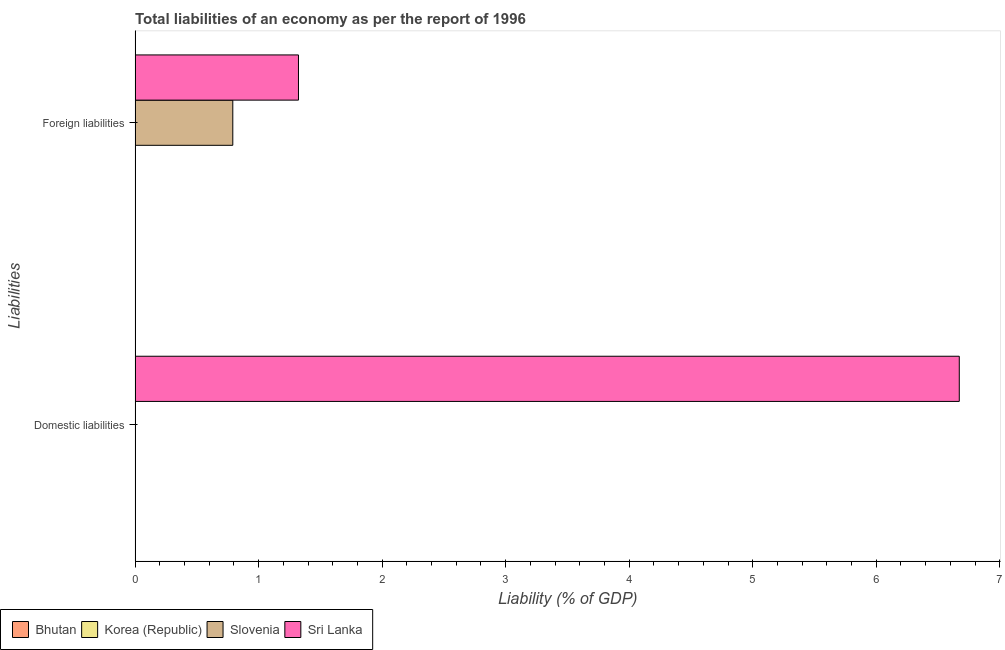How many different coloured bars are there?
Your answer should be compact. 2. Are the number of bars per tick equal to the number of legend labels?
Your answer should be compact. No. Are the number of bars on each tick of the Y-axis equal?
Offer a very short reply. No. How many bars are there on the 1st tick from the top?
Give a very brief answer. 2. How many bars are there on the 2nd tick from the bottom?
Provide a short and direct response. 2. What is the label of the 2nd group of bars from the top?
Your answer should be very brief. Domestic liabilities. What is the incurrence of domestic liabilities in Bhutan?
Offer a terse response. 0. Across all countries, what is the maximum incurrence of domestic liabilities?
Offer a terse response. 6.67. In which country was the incurrence of foreign liabilities maximum?
Provide a short and direct response. Sri Lanka. What is the total incurrence of domestic liabilities in the graph?
Provide a succinct answer. 6.67. What is the difference between the incurrence of foreign liabilities in Sri Lanka and that in Slovenia?
Offer a terse response. 0.53. What is the average incurrence of domestic liabilities per country?
Ensure brevity in your answer.  1.67. What is the difference between the incurrence of foreign liabilities and incurrence of domestic liabilities in Sri Lanka?
Give a very brief answer. -5.35. In how many countries, is the incurrence of domestic liabilities greater than 5.2 %?
Provide a short and direct response. 1. Is the incurrence of foreign liabilities in Slovenia less than that in Sri Lanka?
Ensure brevity in your answer.  Yes. Does the graph contain any zero values?
Make the answer very short. Yes. Where does the legend appear in the graph?
Your answer should be very brief. Bottom left. What is the title of the graph?
Give a very brief answer. Total liabilities of an economy as per the report of 1996. What is the label or title of the X-axis?
Ensure brevity in your answer.  Liability (% of GDP). What is the label or title of the Y-axis?
Your answer should be compact. Liabilities. What is the Liability (% of GDP) of Slovenia in Domestic liabilities?
Provide a succinct answer. 0. What is the Liability (% of GDP) of Sri Lanka in Domestic liabilities?
Ensure brevity in your answer.  6.67. What is the Liability (% of GDP) of Bhutan in Foreign liabilities?
Your response must be concise. 0. What is the Liability (% of GDP) in Korea (Republic) in Foreign liabilities?
Ensure brevity in your answer.  0. What is the Liability (% of GDP) in Slovenia in Foreign liabilities?
Keep it short and to the point. 0.79. What is the Liability (% of GDP) of Sri Lanka in Foreign liabilities?
Ensure brevity in your answer.  1.32. Across all Liabilities, what is the maximum Liability (% of GDP) in Slovenia?
Keep it short and to the point. 0.79. Across all Liabilities, what is the maximum Liability (% of GDP) of Sri Lanka?
Your response must be concise. 6.67. Across all Liabilities, what is the minimum Liability (% of GDP) of Slovenia?
Give a very brief answer. 0. Across all Liabilities, what is the minimum Liability (% of GDP) of Sri Lanka?
Ensure brevity in your answer.  1.32. What is the total Liability (% of GDP) of Korea (Republic) in the graph?
Your answer should be very brief. 0. What is the total Liability (% of GDP) of Slovenia in the graph?
Ensure brevity in your answer.  0.79. What is the total Liability (% of GDP) of Sri Lanka in the graph?
Provide a succinct answer. 7.99. What is the difference between the Liability (% of GDP) in Sri Lanka in Domestic liabilities and that in Foreign liabilities?
Your answer should be compact. 5.35. What is the average Liability (% of GDP) of Korea (Republic) per Liabilities?
Your answer should be very brief. 0. What is the average Liability (% of GDP) in Slovenia per Liabilities?
Give a very brief answer. 0.4. What is the average Liability (% of GDP) in Sri Lanka per Liabilities?
Make the answer very short. 4. What is the difference between the Liability (% of GDP) of Slovenia and Liability (% of GDP) of Sri Lanka in Foreign liabilities?
Ensure brevity in your answer.  -0.53. What is the ratio of the Liability (% of GDP) of Sri Lanka in Domestic liabilities to that in Foreign liabilities?
Provide a succinct answer. 5.04. What is the difference between the highest and the second highest Liability (% of GDP) in Sri Lanka?
Your response must be concise. 5.35. What is the difference between the highest and the lowest Liability (% of GDP) of Slovenia?
Your response must be concise. 0.79. What is the difference between the highest and the lowest Liability (% of GDP) in Sri Lanka?
Your response must be concise. 5.35. 